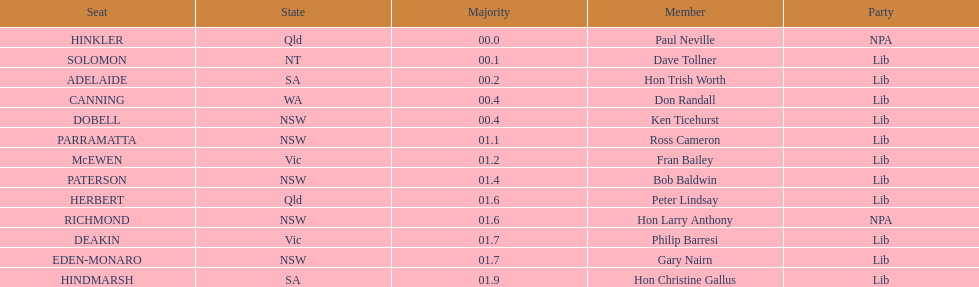Is fran bailey associated with victoria or western australia? Vic. 